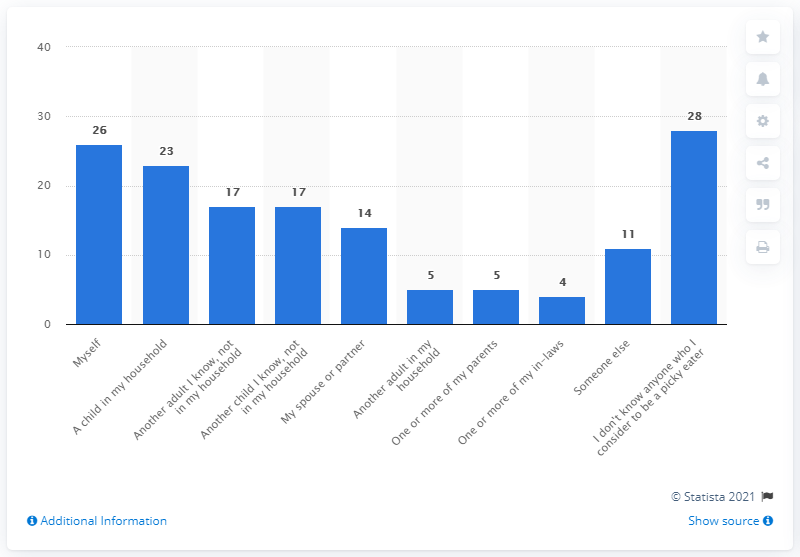Outline some significant characteristics in this image. According to the responses received, 26% of the participants identified themselves as picky eaters. 